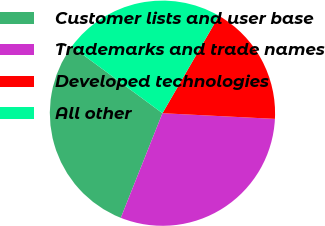Convert chart. <chart><loc_0><loc_0><loc_500><loc_500><pie_chart><fcel>Customer lists and user base<fcel>Trademarks and trade names<fcel>Developed technologies<fcel>All other<nl><fcel>29.07%<fcel>30.23%<fcel>17.44%<fcel>23.26%<nl></chart> 